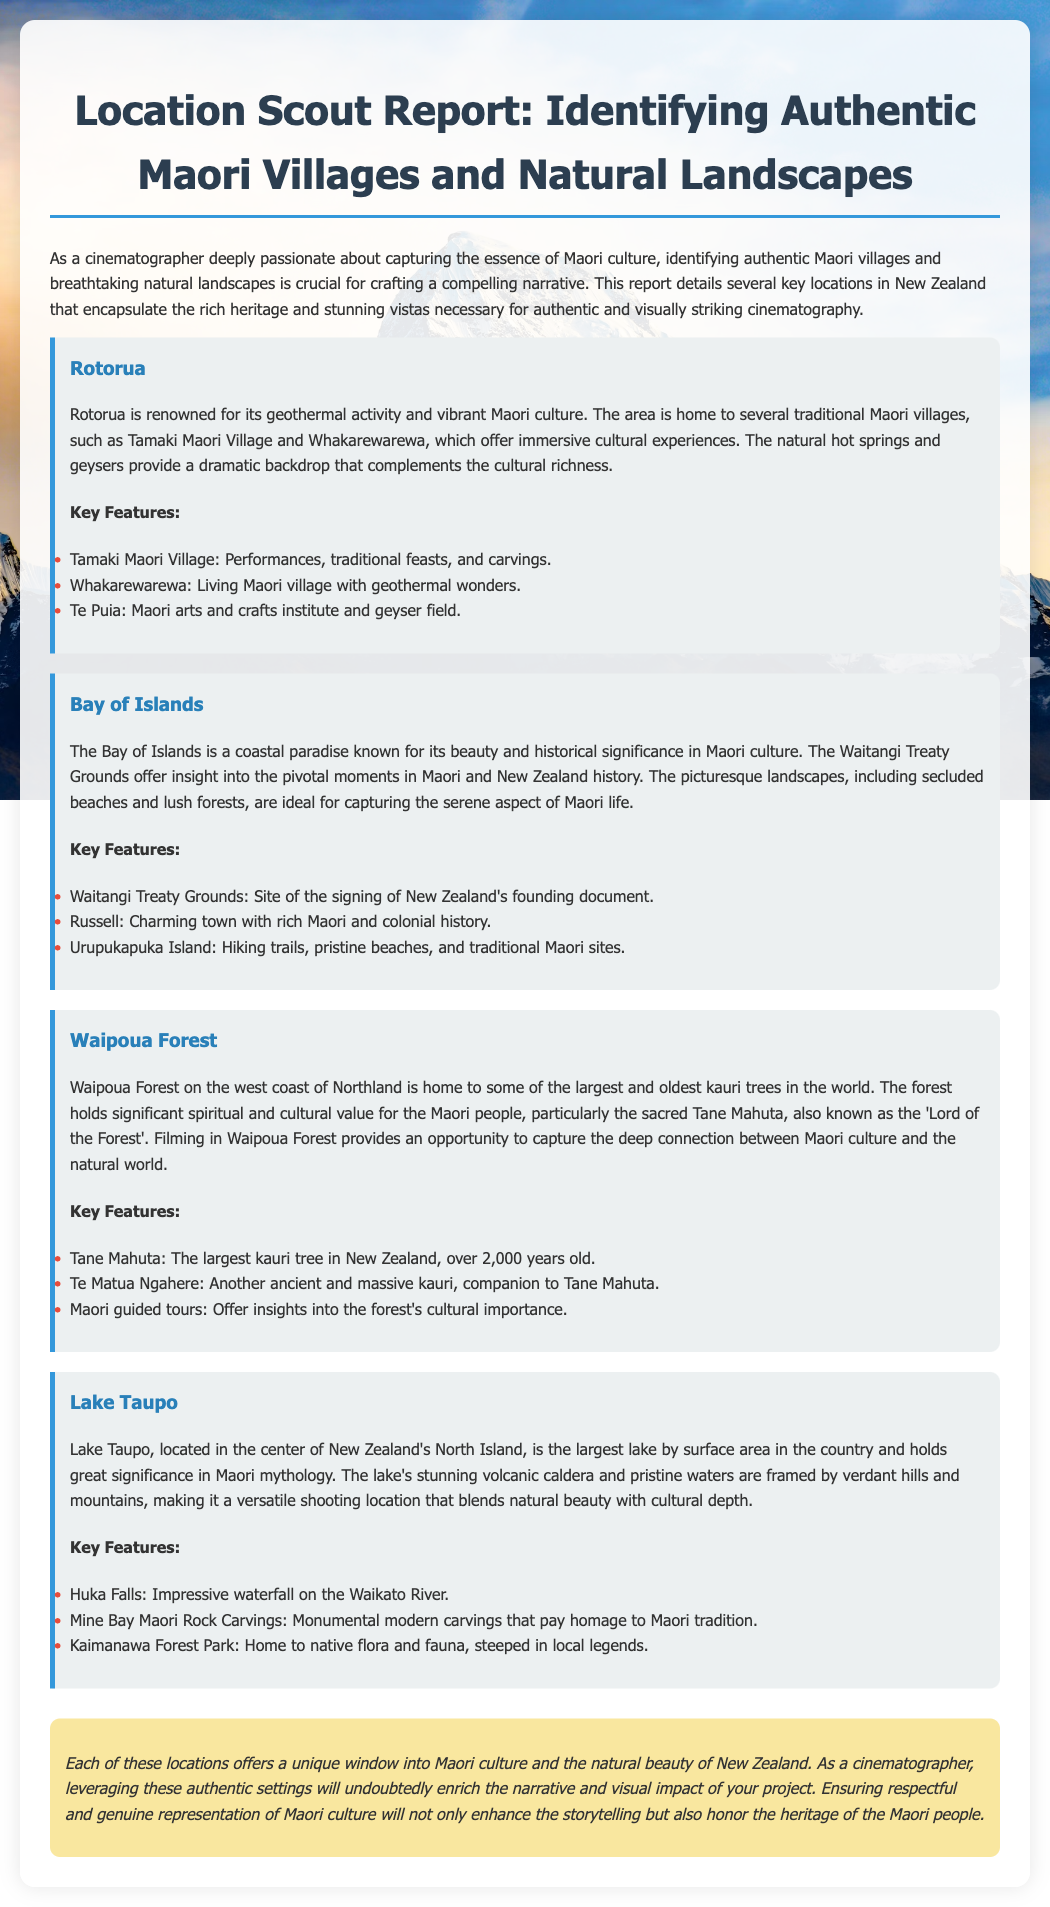What is the purpose of the report? The report details several key locations in New Zealand that encapsulate the rich heritage and stunning vistas necessary for authentic and visually striking cinematography.
Answer: Authentic cinematography What are the three key features of Rotorua? The key features mentioned for Rotorua include Tamaki Maori Village, Whakarewarewa, and Te Puia.
Answer: Tamaki Maori Village, Whakarewarewa, Te Puia Which location is known for the largest kauri tree? Waipoua Forest is mentioned as the location for Tane Mahuta, the largest kauri tree in New Zealand.
Answer: Waipoua Forest What historic site is found in the Bay of Islands? The Waitangi Treaty Grounds is a significant historical site located in the Bay of Islands.
Answer: Waitangi Treaty Grounds How many features are listed for Lake Taupo? Three key features are highlighted for Lake Taupo: Huka Falls, Mine Bay Maori Rock Carvings, and Kaimanawa Forest Park.
Answer: Three What does the report emphasize for cinematographers regarding Maori culture? The report emphasizes ensuring respectful and genuine representation of Maori culture to enhance storytelling and honor Maori heritage.
Answer: Respectful representation What significant element does Waipoua Forest hold for Maori people? Waipoua Forest holds significant spiritual and cultural value for the Maori people.
Answer: Spiritual value Where is Lake Taupo situated? Lake Taupo is located in the center of New Zealand's North Island.
Answer: Center of North Island 